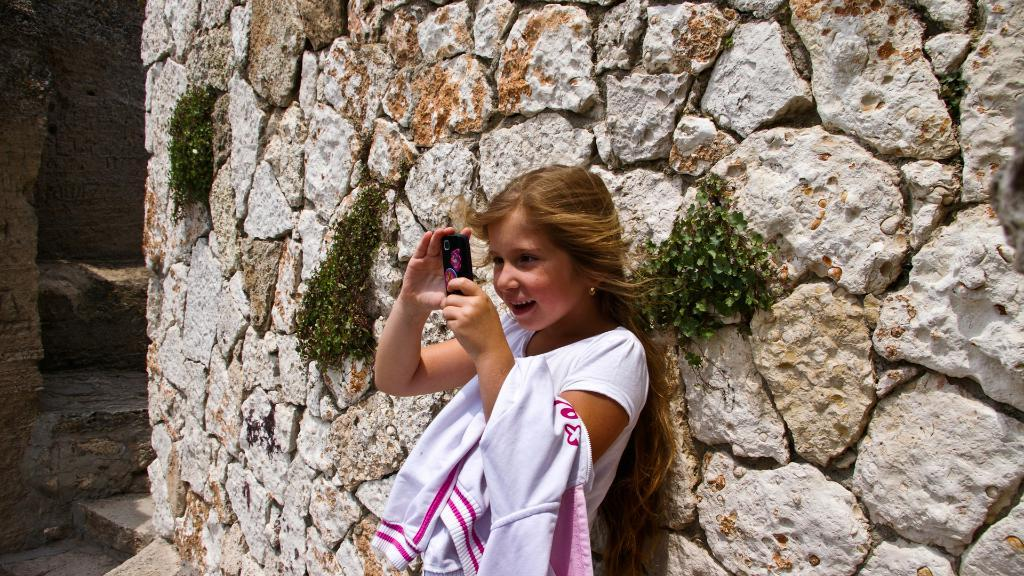Who is the main subject in the image? There is a girl in the image. What is the girl holding in the image? The girl is holding a mobile phone. What type of structure can be seen in the image? There is a rock wall in the image. What is growing on the rock wall? There are plants attached to the rock wall. What day of the week is it in the image? The day of the week is not mentioned or depicted in the image. Can you tell me how many horses are present in the image? There are no horses present in the image. 